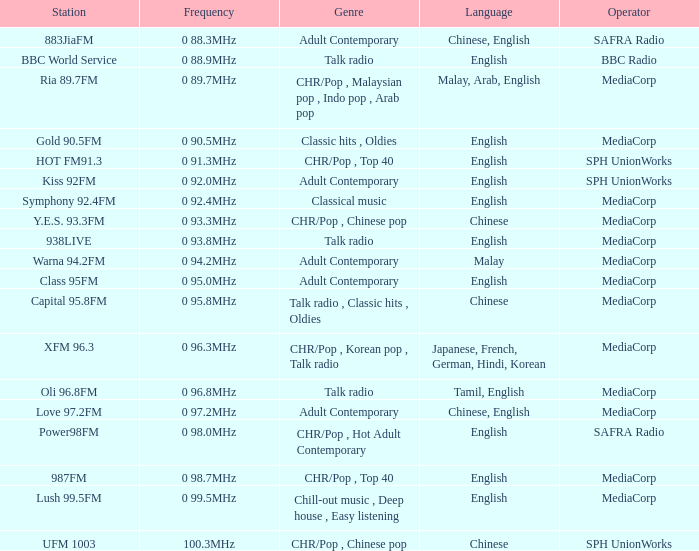Which station is operated by BBC Radio under the talk radio genre? BBC World Service. 